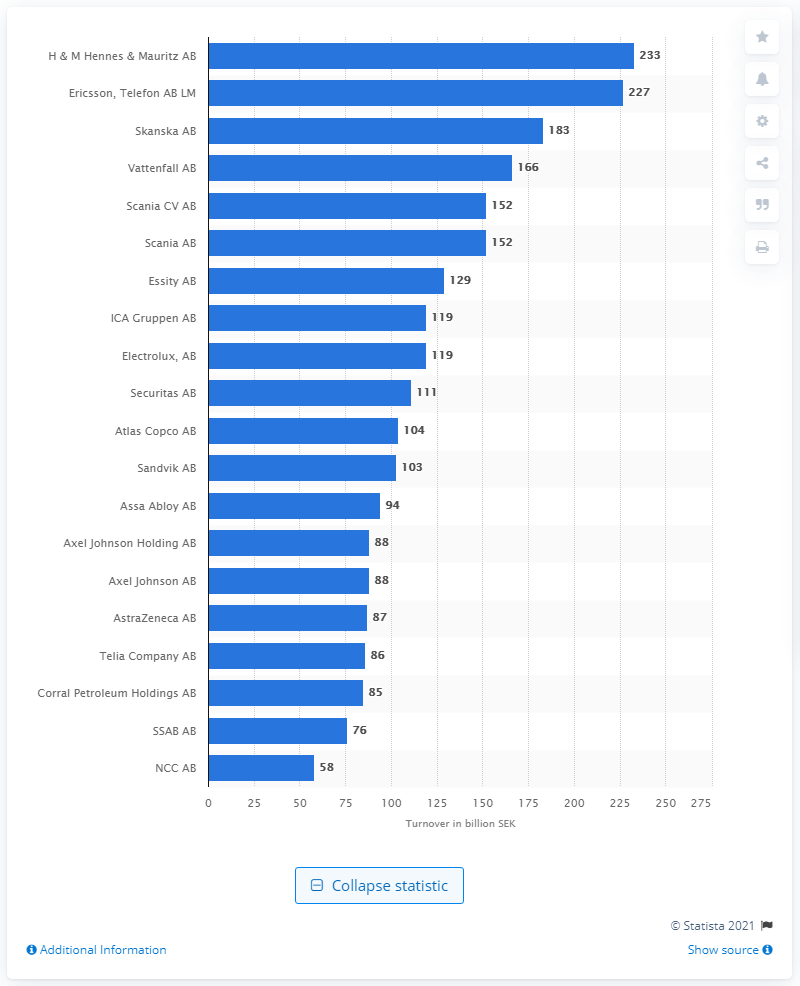Outline some significant characteristics in this image. H&M's turnover in Swedish kronor in 2021 was approximately 233.. According to a list of the top 20 Stockholm-based companies with the highest turnover in 2021, Skanska AB was ranked third. 